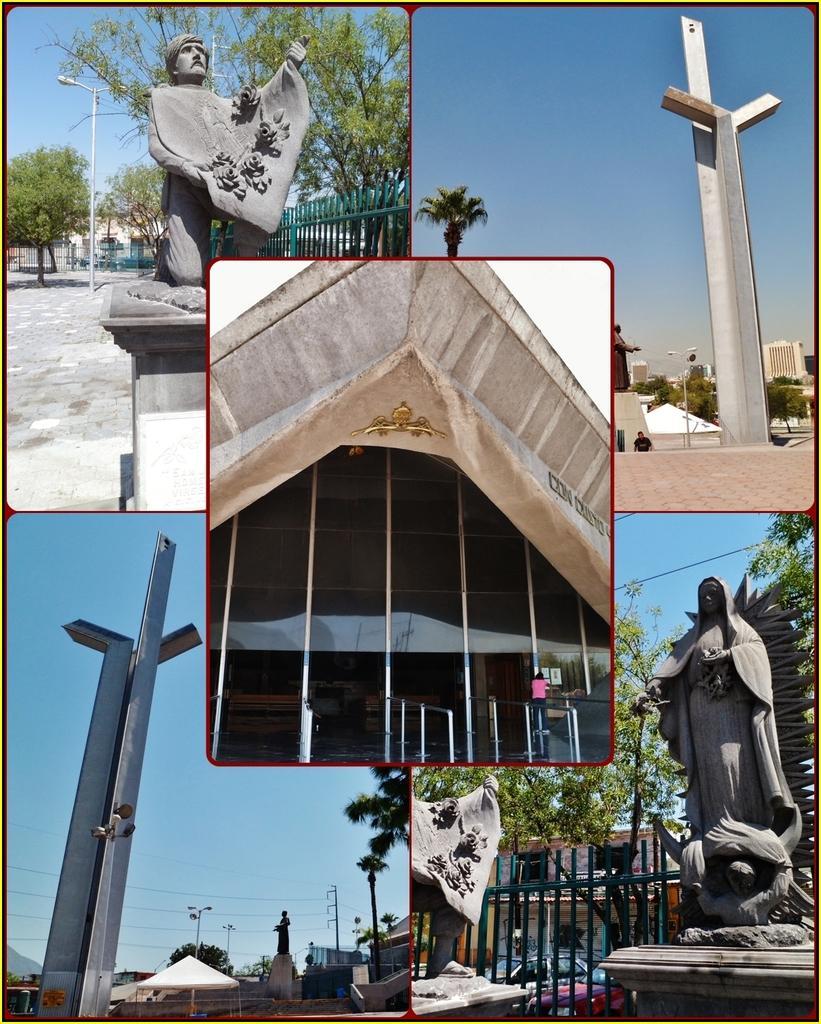How would you summarize this image in a sentence or two? In this image I can see few pictures , on the pictures I can see sculptures and boards ,trees and fence and building visible. And the sky visible. 